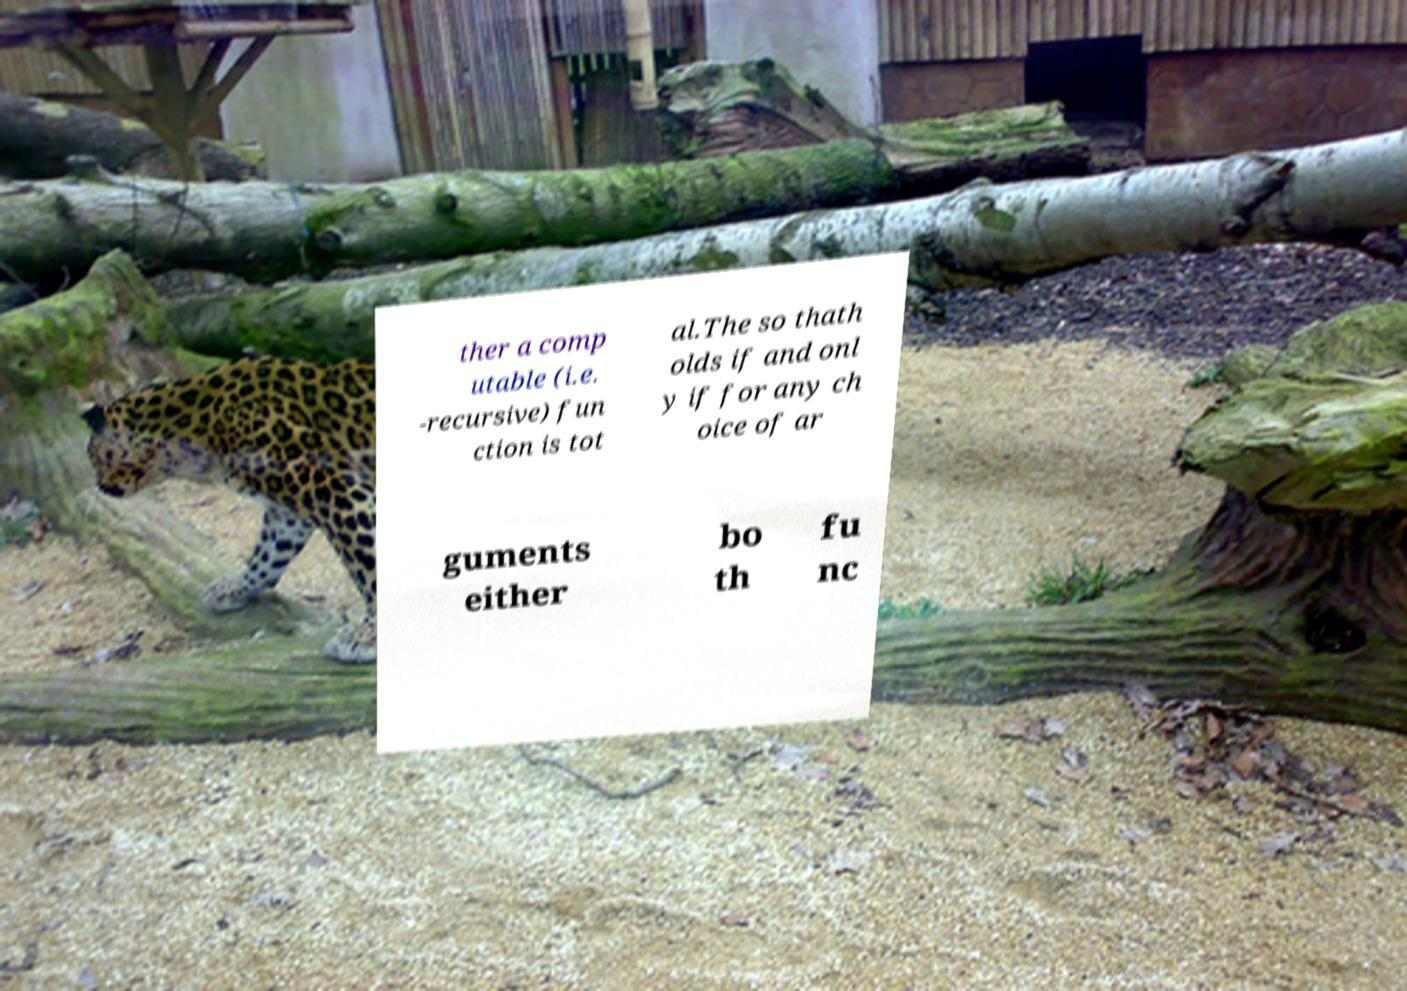Can you read and provide the text displayed in the image?This photo seems to have some interesting text. Can you extract and type it out for me? ther a comp utable (i.e. -recursive) fun ction is tot al.The so thath olds if and onl y if for any ch oice of ar guments either bo th fu nc 